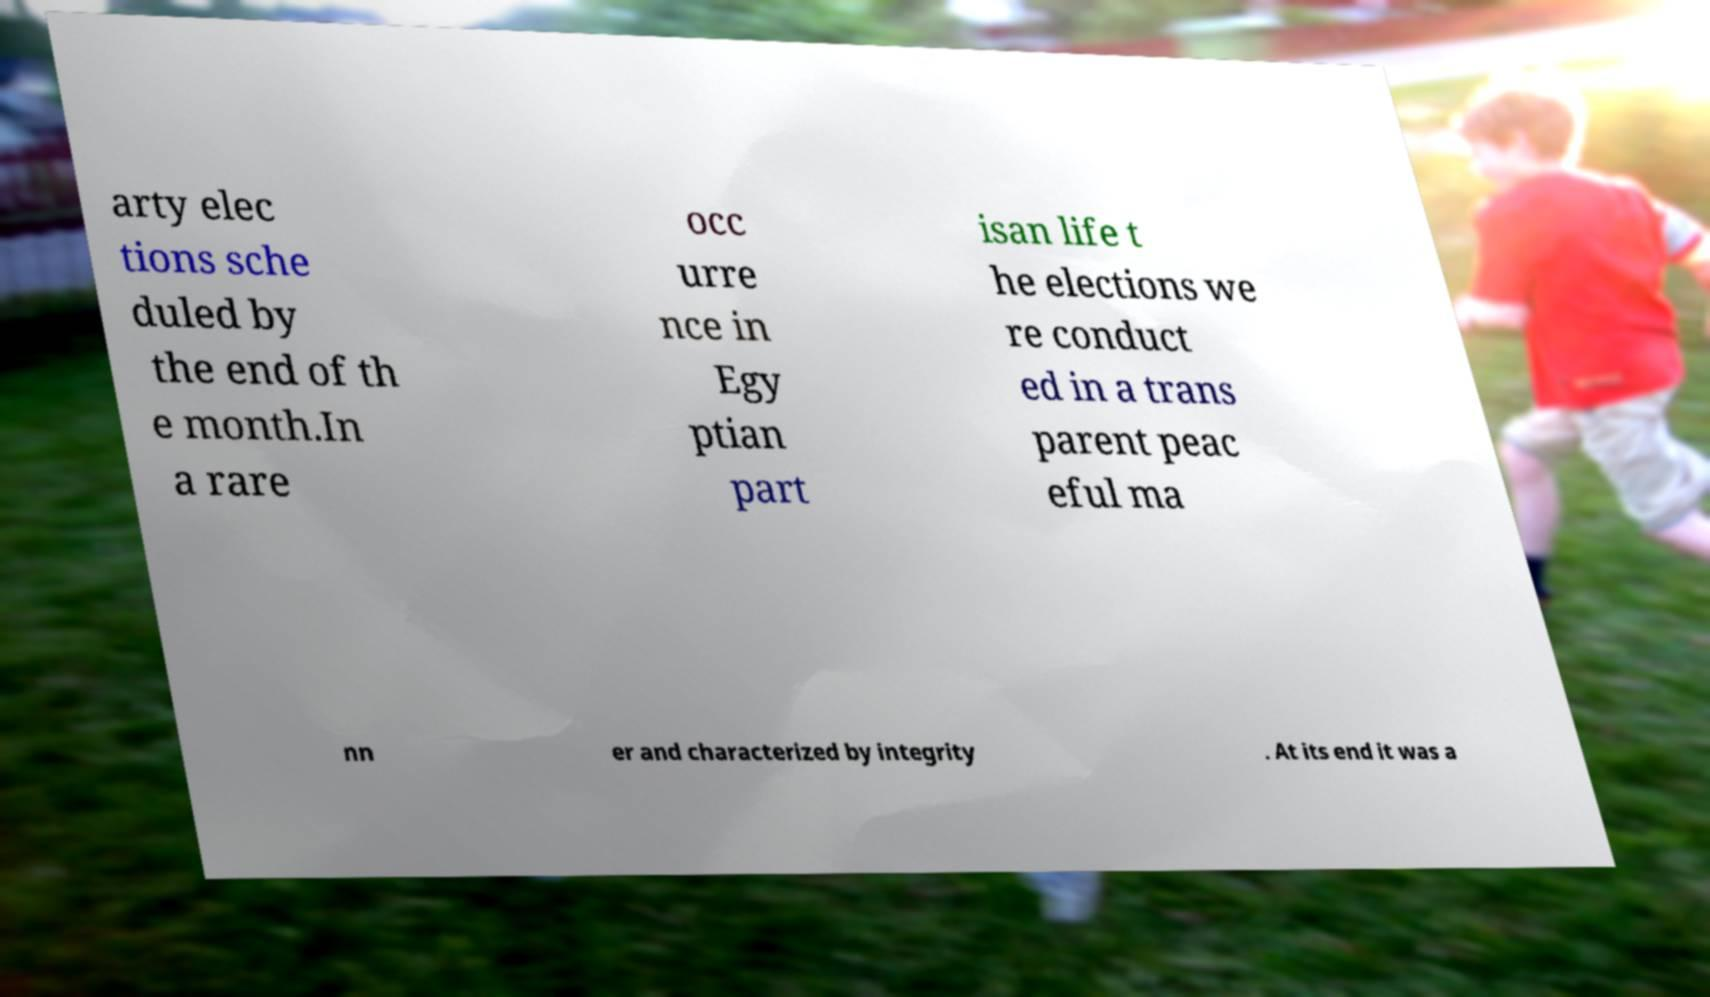Can you accurately transcribe the text from the provided image for me? arty elec tions sche duled by the end of th e month.In a rare occ urre nce in Egy ptian part isan life t he elections we re conduct ed in a trans parent peac eful ma nn er and characterized by integrity . At its end it was a 